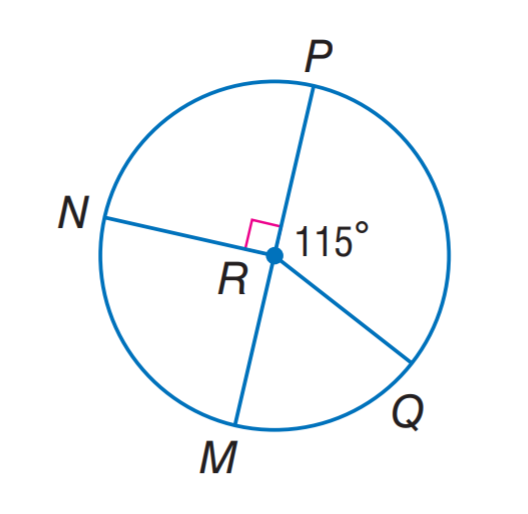Answer the mathemtical geometry problem and directly provide the correct option letter.
Question: P M is a diameter of \odot R. Find m \widehat M Q.
Choices: A: 45 B: 55 C: 65 D: 75 C 